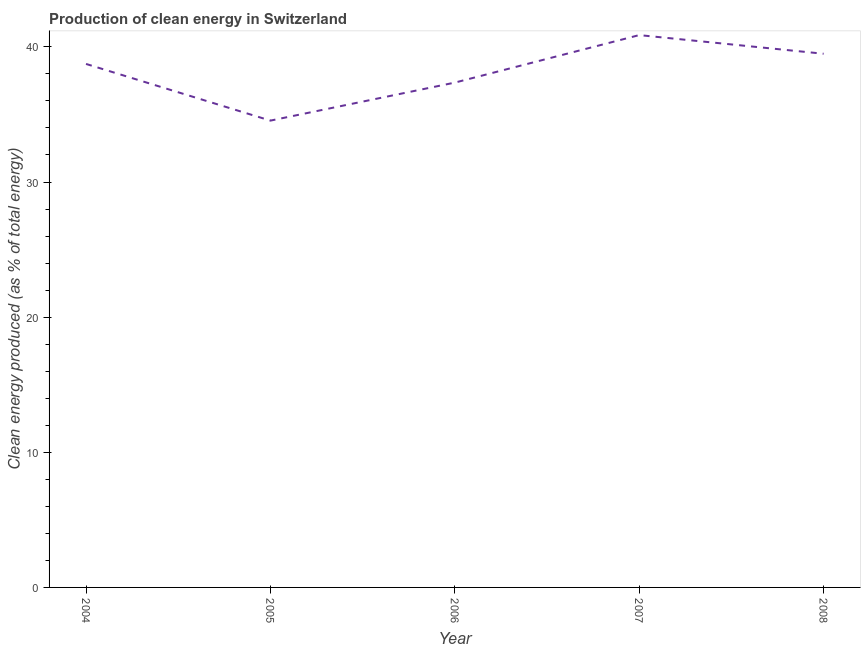What is the production of clean energy in 2008?
Provide a short and direct response. 39.49. Across all years, what is the maximum production of clean energy?
Keep it short and to the point. 40.87. Across all years, what is the minimum production of clean energy?
Ensure brevity in your answer.  34.54. In which year was the production of clean energy maximum?
Your answer should be very brief. 2007. In which year was the production of clean energy minimum?
Your answer should be very brief. 2005. What is the sum of the production of clean energy?
Offer a terse response. 191. What is the difference between the production of clean energy in 2005 and 2008?
Offer a very short reply. -4.95. What is the average production of clean energy per year?
Your response must be concise. 38.2. What is the median production of clean energy?
Offer a very short reply. 38.74. In how many years, is the production of clean energy greater than 20 %?
Ensure brevity in your answer.  5. What is the ratio of the production of clean energy in 2005 to that in 2006?
Offer a very short reply. 0.92. What is the difference between the highest and the second highest production of clean energy?
Keep it short and to the point. 1.38. Is the sum of the production of clean energy in 2005 and 2008 greater than the maximum production of clean energy across all years?
Your response must be concise. Yes. What is the difference between the highest and the lowest production of clean energy?
Offer a very short reply. 6.33. What is the difference between two consecutive major ticks on the Y-axis?
Make the answer very short. 10. Does the graph contain any zero values?
Give a very brief answer. No. What is the title of the graph?
Provide a short and direct response. Production of clean energy in Switzerland. What is the label or title of the X-axis?
Provide a succinct answer. Year. What is the label or title of the Y-axis?
Make the answer very short. Clean energy produced (as % of total energy). What is the Clean energy produced (as % of total energy) in 2004?
Give a very brief answer. 38.74. What is the Clean energy produced (as % of total energy) in 2005?
Offer a terse response. 34.54. What is the Clean energy produced (as % of total energy) of 2006?
Make the answer very short. 37.36. What is the Clean energy produced (as % of total energy) in 2007?
Give a very brief answer. 40.87. What is the Clean energy produced (as % of total energy) of 2008?
Make the answer very short. 39.49. What is the difference between the Clean energy produced (as % of total energy) in 2004 and 2005?
Offer a very short reply. 4.19. What is the difference between the Clean energy produced (as % of total energy) in 2004 and 2006?
Make the answer very short. 1.38. What is the difference between the Clean energy produced (as % of total energy) in 2004 and 2007?
Your answer should be very brief. -2.13. What is the difference between the Clean energy produced (as % of total energy) in 2004 and 2008?
Your answer should be very brief. -0.75. What is the difference between the Clean energy produced (as % of total energy) in 2005 and 2006?
Make the answer very short. -2.81. What is the difference between the Clean energy produced (as % of total energy) in 2005 and 2007?
Ensure brevity in your answer.  -6.33. What is the difference between the Clean energy produced (as % of total energy) in 2005 and 2008?
Offer a terse response. -4.95. What is the difference between the Clean energy produced (as % of total energy) in 2006 and 2007?
Make the answer very short. -3.52. What is the difference between the Clean energy produced (as % of total energy) in 2006 and 2008?
Ensure brevity in your answer.  -2.14. What is the difference between the Clean energy produced (as % of total energy) in 2007 and 2008?
Give a very brief answer. 1.38. What is the ratio of the Clean energy produced (as % of total energy) in 2004 to that in 2005?
Ensure brevity in your answer.  1.12. What is the ratio of the Clean energy produced (as % of total energy) in 2004 to that in 2007?
Your answer should be very brief. 0.95. What is the ratio of the Clean energy produced (as % of total energy) in 2005 to that in 2006?
Give a very brief answer. 0.93. What is the ratio of the Clean energy produced (as % of total energy) in 2005 to that in 2007?
Make the answer very short. 0.84. What is the ratio of the Clean energy produced (as % of total energy) in 2006 to that in 2007?
Offer a terse response. 0.91. What is the ratio of the Clean energy produced (as % of total energy) in 2006 to that in 2008?
Give a very brief answer. 0.95. What is the ratio of the Clean energy produced (as % of total energy) in 2007 to that in 2008?
Give a very brief answer. 1.03. 